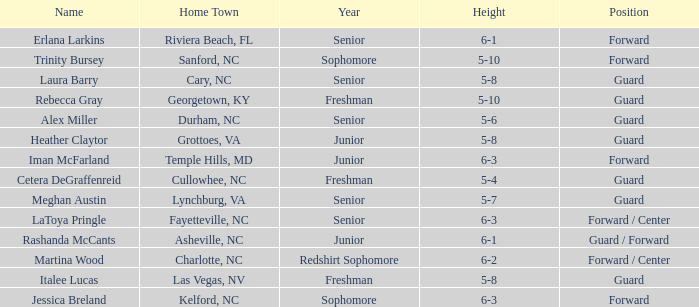What is the height of the player from Las Vegas, NV? 5-8. 